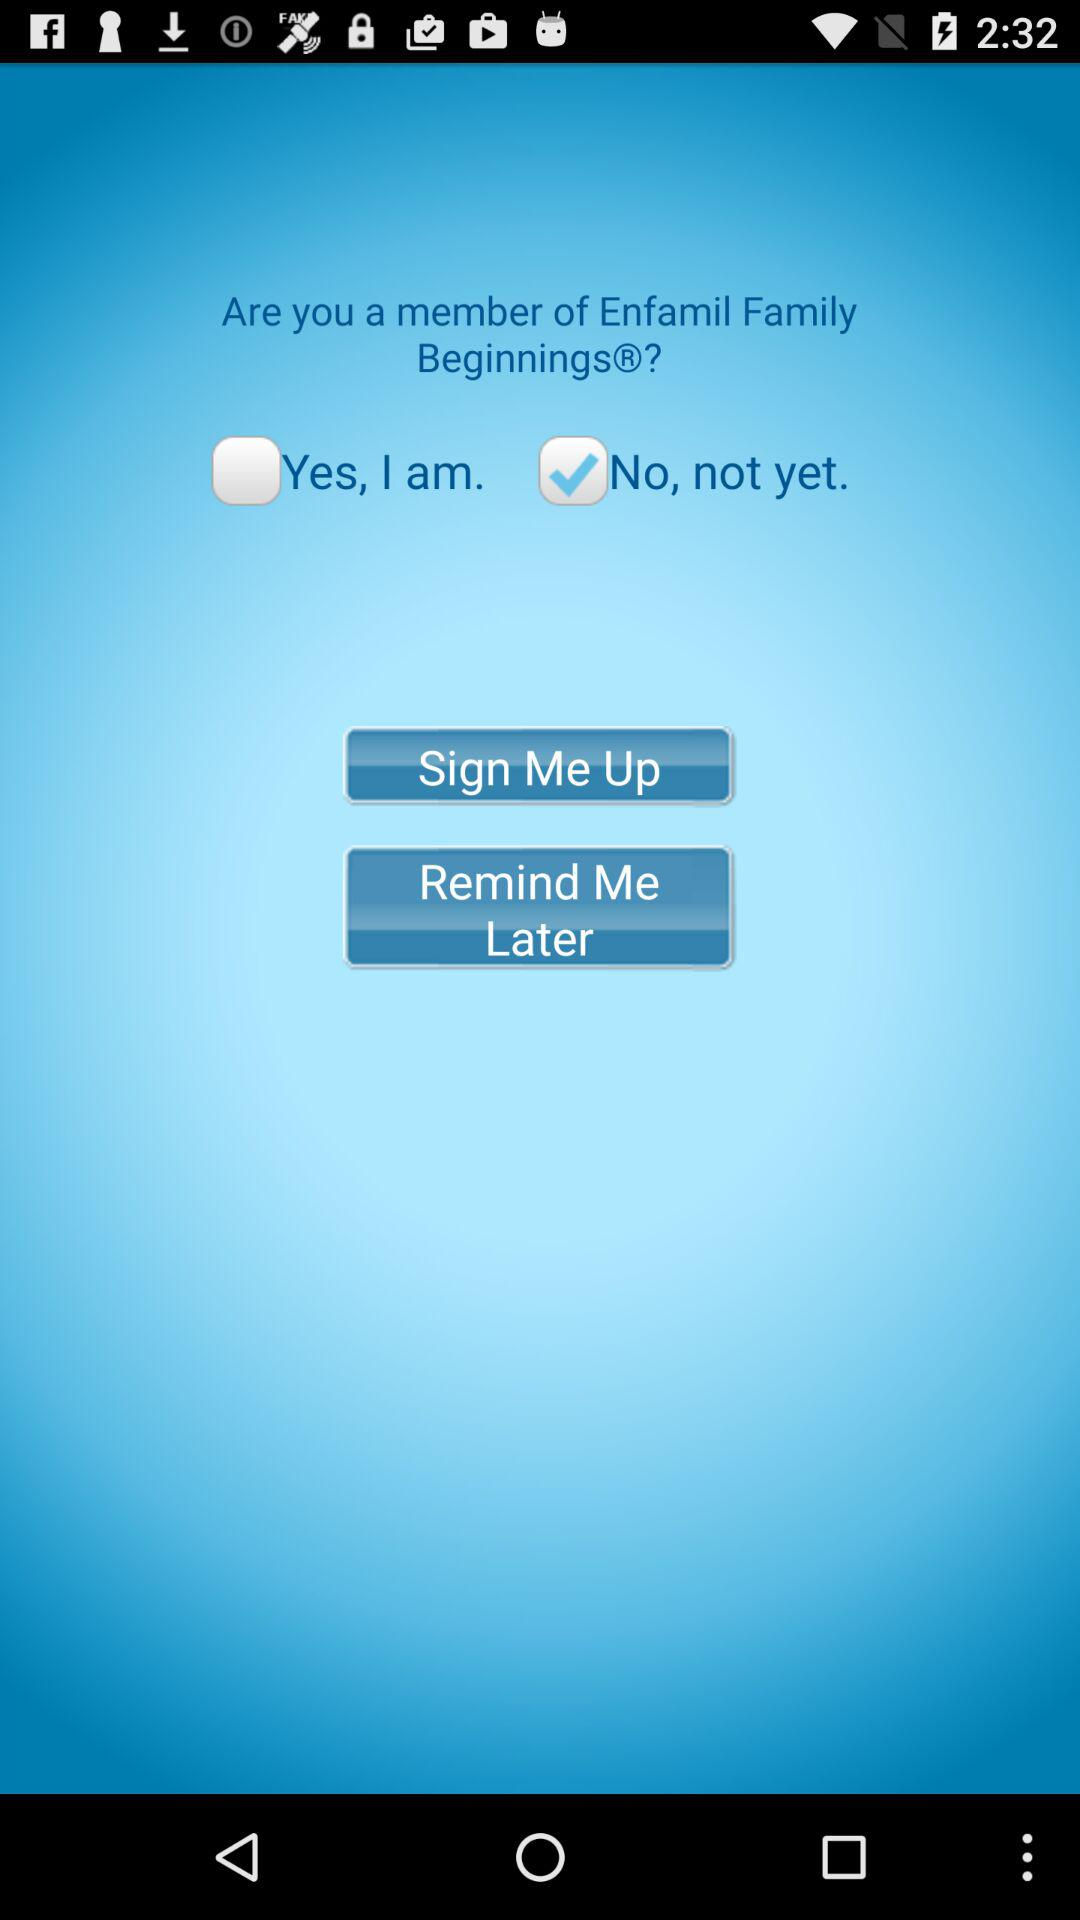Which checkbox is checked? The checked checkbox is "No, not yet". 